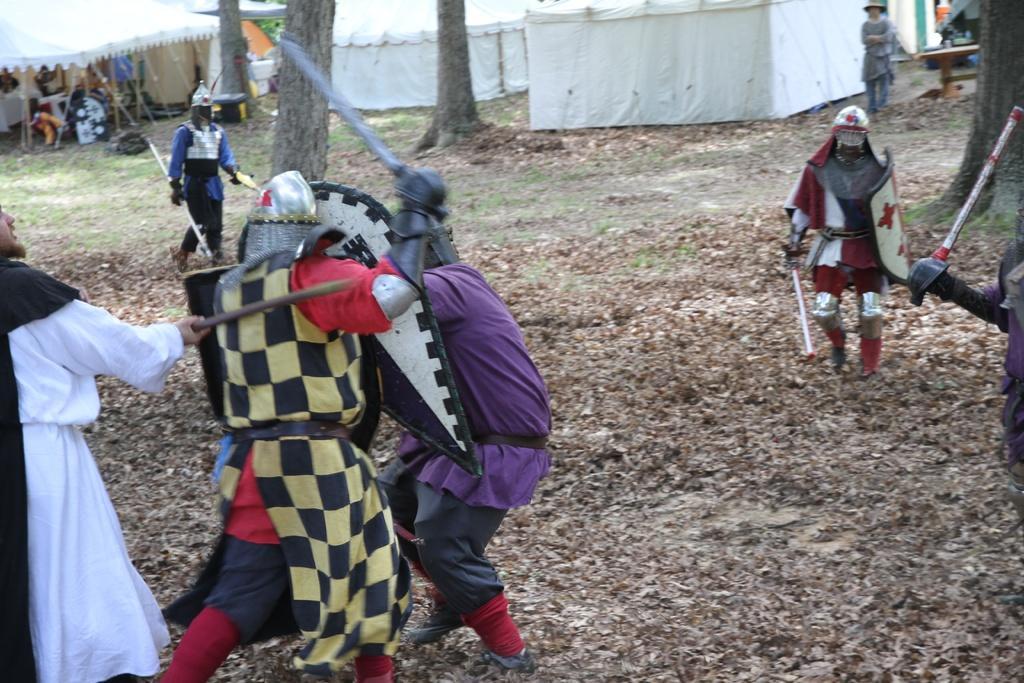Can you describe this image briefly? In this image there are men holding an object, there is a woman standing, there are tree trunks, there are tents towards the top of the image, there are ropes, there are objects under the tents. 